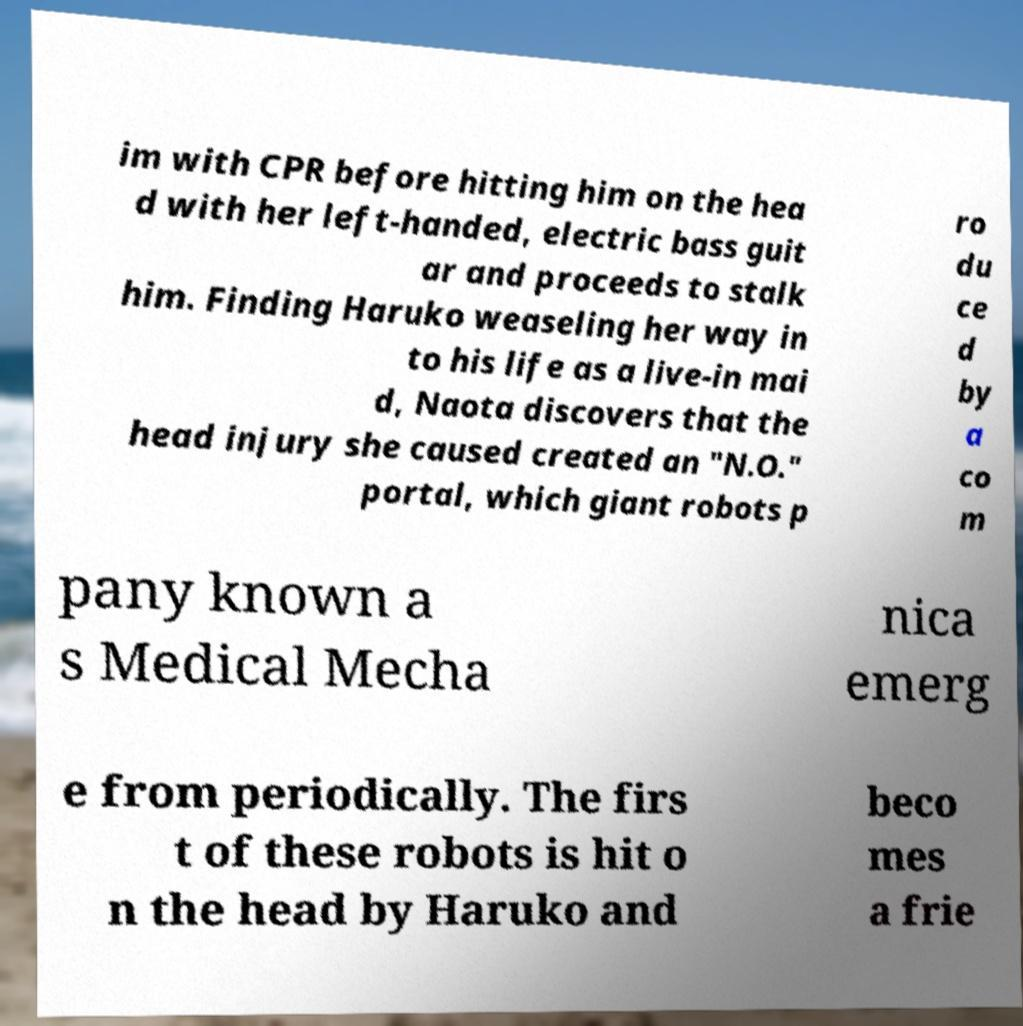Can you read and provide the text displayed in the image?This photo seems to have some interesting text. Can you extract and type it out for me? im with CPR before hitting him on the hea d with her left-handed, electric bass guit ar and proceeds to stalk him. Finding Haruko weaseling her way in to his life as a live-in mai d, Naota discovers that the head injury she caused created an "N.O." portal, which giant robots p ro du ce d by a co m pany known a s Medical Mecha nica emerg e from periodically. The firs t of these robots is hit o n the head by Haruko and beco mes a frie 